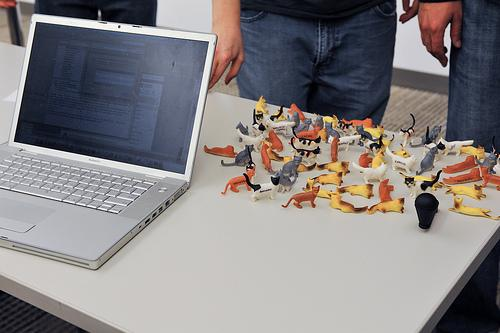List the types of cats depicted by the figurines on the table. There's a white cat with long fur, an orange cat, an Abyssinian cat, two calico cats with tails up, a black and white cat, and a grey cat on its hind legs. How many people can be seen in the image and describe their actions? There are two people wearing jeans, one with their hand on the table and the other standing beside him behind the table. Analyze the image's sentiment by examining the items in the image. The sentiment seems light-hearted and playful, with a collection of small, colorful cat figurines on the table and people casually gathered behind it. Explain what the person on the left is doing with their hands. The person on the left has their hands on the side of their pants near the waist. Identify and briefly describe the main objects on the laptop. The laptop has a keyboard, trackpad, spacebar, power button, camera, extension inputs, and a mousepad. Discuss the possible interaction between the black and white cat figurine and the round black object. The black and white cat figurine might be looking curiously at the round black object, as if it were a toy or an object it wants to investigate. Count and describe the main figures on top of the table. There are many small plastic cats with different colors and poses, including some that are sitting, standing, and lying down. What type of electronic device is prominently displayed in the image? A silver laptop computer with its screen showing text and power button visible. Which two objects in the image have almost the same Width and Height dimensions? The open laptop (Width: 207, Height: 207) and the pair of blue jeans (Width: 174, Height: 174) have almost the same Width and Height dimensions. Provide a description of the furniture present in the image. There is a long grey table with a white rectangular top on which an open laptop and many cat figurines are placed. A patterned tan and brown rug lies on the floor below the table. Can you find a person wearing a bright pink dress in the image? The only people in the image are mentioned as wearing jeans, not a pink dress. Can you find a blue and green striped cat figurine on the table? All cat figurines have a specific color and pattern mentioned, but none of them are described as blue and green striped. Does the table have a vase with flowers on it? There is no mention of a vase or flowers on the table in the image; only figurines, a laptop, and people are described. Is there a large red dog figurine on the table? There are only cat figurines on the table, not a dog, and there is no mention of a red figurine. Is there a person holding an umbrella in the image? None of the people in the image are described as holding an umbrella or any other object. Is there a purple polka-dotted rug on the floor? The only rug mentioned in the image is a tan and brown patterned rug, not a purple polka-dotted one. 